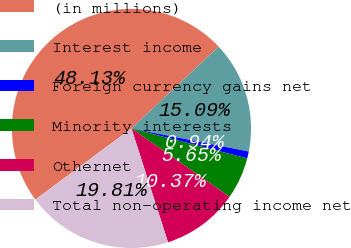Convert chart. <chart><loc_0><loc_0><loc_500><loc_500><pie_chart><fcel>(in millions)<fcel>Interest income<fcel>Foreign currency gains net<fcel>Minority interests<fcel>Othernet<fcel>Total non-operating income net<nl><fcel>48.13%<fcel>15.09%<fcel>0.94%<fcel>5.65%<fcel>10.37%<fcel>19.81%<nl></chart> 